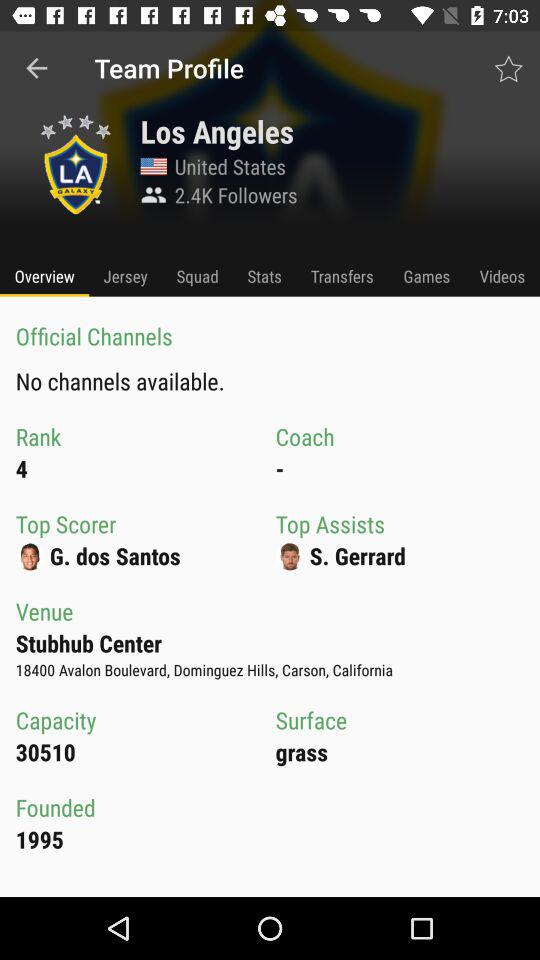How many followers are there? There are 2.4K followers. 